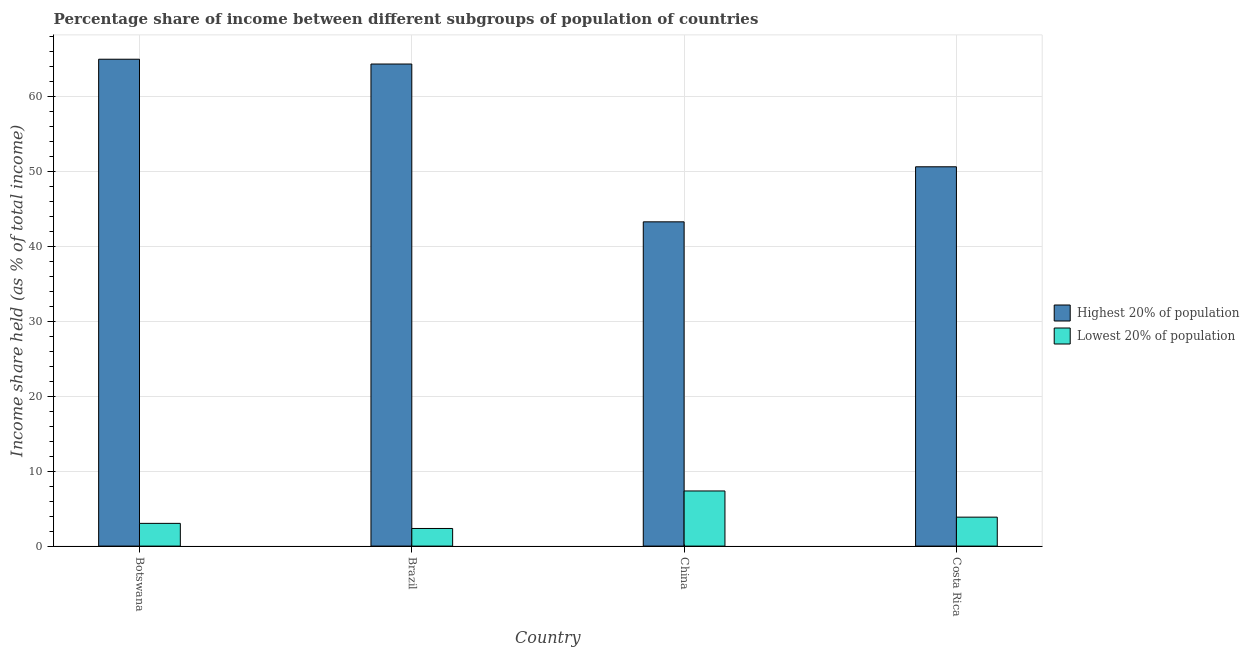Are the number of bars on each tick of the X-axis equal?
Offer a very short reply. Yes. How many bars are there on the 2nd tick from the right?
Ensure brevity in your answer.  2. In how many cases, is the number of bars for a given country not equal to the number of legend labels?
Ensure brevity in your answer.  0. What is the income share held by lowest 20% of the population in Botswana?
Provide a short and direct response. 3.03. Across all countries, what is the maximum income share held by lowest 20% of the population?
Make the answer very short. 7.35. Across all countries, what is the minimum income share held by highest 20% of the population?
Your answer should be compact. 43.23. In which country was the income share held by highest 20% of the population maximum?
Offer a terse response. Botswana. What is the total income share held by lowest 20% of the population in the graph?
Offer a terse response. 16.59. What is the difference between the income share held by highest 20% of the population in Botswana and that in China?
Make the answer very short. 21.68. What is the difference between the income share held by lowest 20% of the population in Brazil and the income share held by highest 20% of the population in Costa Rica?
Keep it short and to the point. -48.22. What is the average income share held by lowest 20% of the population per country?
Your response must be concise. 4.15. What is the difference between the income share held by highest 20% of the population and income share held by lowest 20% of the population in Botswana?
Your answer should be compact. 61.88. In how many countries, is the income share held by lowest 20% of the population greater than 28 %?
Offer a very short reply. 0. What is the ratio of the income share held by highest 20% of the population in China to that in Costa Rica?
Keep it short and to the point. 0.85. Is the income share held by highest 20% of the population in Botswana less than that in Brazil?
Keep it short and to the point. No. Is the difference between the income share held by lowest 20% of the population in Botswana and Costa Rica greater than the difference between the income share held by highest 20% of the population in Botswana and Costa Rica?
Your response must be concise. No. What is the difference between the highest and the second highest income share held by highest 20% of the population?
Your response must be concise. 0.64. What is the difference between the highest and the lowest income share held by lowest 20% of the population?
Your response must be concise. 5. Is the sum of the income share held by lowest 20% of the population in Botswana and Costa Rica greater than the maximum income share held by highest 20% of the population across all countries?
Provide a succinct answer. No. What does the 1st bar from the left in Brazil represents?
Give a very brief answer. Highest 20% of population. What does the 1st bar from the right in Botswana represents?
Give a very brief answer. Lowest 20% of population. Are all the bars in the graph horizontal?
Keep it short and to the point. No. How many countries are there in the graph?
Provide a succinct answer. 4. Does the graph contain any zero values?
Your response must be concise. No. How many legend labels are there?
Your answer should be very brief. 2. How are the legend labels stacked?
Provide a succinct answer. Vertical. What is the title of the graph?
Provide a succinct answer. Percentage share of income between different subgroups of population of countries. Does "Diesel" appear as one of the legend labels in the graph?
Your answer should be very brief. No. What is the label or title of the X-axis?
Offer a very short reply. Country. What is the label or title of the Y-axis?
Keep it short and to the point. Income share held (as % of total income). What is the Income share held (as % of total income) of Highest 20% of population in Botswana?
Give a very brief answer. 64.91. What is the Income share held (as % of total income) of Lowest 20% of population in Botswana?
Provide a short and direct response. 3.03. What is the Income share held (as % of total income) in Highest 20% of population in Brazil?
Provide a succinct answer. 64.27. What is the Income share held (as % of total income) of Lowest 20% of population in Brazil?
Your answer should be compact. 2.35. What is the Income share held (as % of total income) in Highest 20% of population in China?
Offer a terse response. 43.23. What is the Income share held (as % of total income) of Lowest 20% of population in China?
Offer a terse response. 7.35. What is the Income share held (as % of total income) in Highest 20% of population in Costa Rica?
Keep it short and to the point. 50.57. What is the Income share held (as % of total income) of Lowest 20% of population in Costa Rica?
Keep it short and to the point. 3.86. Across all countries, what is the maximum Income share held (as % of total income) in Highest 20% of population?
Give a very brief answer. 64.91. Across all countries, what is the maximum Income share held (as % of total income) in Lowest 20% of population?
Offer a very short reply. 7.35. Across all countries, what is the minimum Income share held (as % of total income) of Highest 20% of population?
Make the answer very short. 43.23. Across all countries, what is the minimum Income share held (as % of total income) in Lowest 20% of population?
Give a very brief answer. 2.35. What is the total Income share held (as % of total income) in Highest 20% of population in the graph?
Give a very brief answer. 222.98. What is the total Income share held (as % of total income) in Lowest 20% of population in the graph?
Provide a short and direct response. 16.59. What is the difference between the Income share held (as % of total income) in Highest 20% of population in Botswana and that in Brazil?
Keep it short and to the point. 0.64. What is the difference between the Income share held (as % of total income) of Lowest 20% of population in Botswana and that in Brazil?
Offer a very short reply. 0.68. What is the difference between the Income share held (as % of total income) of Highest 20% of population in Botswana and that in China?
Keep it short and to the point. 21.68. What is the difference between the Income share held (as % of total income) in Lowest 20% of population in Botswana and that in China?
Give a very brief answer. -4.32. What is the difference between the Income share held (as % of total income) of Highest 20% of population in Botswana and that in Costa Rica?
Provide a short and direct response. 14.34. What is the difference between the Income share held (as % of total income) in Lowest 20% of population in Botswana and that in Costa Rica?
Give a very brief answer. -0.83. What is the difference between the Income share held (as % of total income) in Highest 20% of population in Brazil and that in China?
Your response must be concise. 21.04. What is the difference between the Income share held (as % of total income) of Highest 20% of population in Brazil and that in Costa Rica?
Provide a short and direct response. 13.7. What is the difference between the Income share held (as % of total income) of Lowest 20% of population in Brazil and that in Costa Rica?
Keep it short and to the point. -1.51. What is the difference between the Income share held (as % of total income) in Highest 20% of population in China and that in Costa Rica?
Give a very brief answer. -7.34. What is the difference between the Income share held (as % of total income) of Lowest 20% of population in China and that in Costa Rica?
Your answer should be very brief. 3.49. What is the difference between the Income share held (as % of total income) in Highest 20% of population in Botswana and the Income share held (as % of total income) in Lowest 20% of population in Brazil?
Provide a short and direct response. 62.56. What is the difference between the Income share held (as % of total income) in Highest 20% of population in Botswana and the Income share held (as % of total income) in Lowest 20% of population in China?
Provide a short and direct response. 57.56. What is the difference between the Income share held (as % of total income) of Highest 20% of population in Botswana and the Income share held (as % of total income) of Lowest 20% of population in Costa Rica?
Ensure brevity in your answer.  61.05. What is the difference between the Income share held (as % of total income) in Highest 20% of population in Brazil and the Income share held (as % of total income) in Lowest 20% of population in China?
Offer a terse response. 56.92. What is the difference between the Income share held (as % of total income) of Highest 20% of population in Brazil and the Income share held (as % of total income) of Lowest 20% of population in Costa Rica?
Offer a very short reply. 60.41. What is the difference between the Income share held (as % of total income) of Highest 20% of population in China and the Income share held (as % of total income) of Lowest 20% of population in Costa Rica?
Offer a very short reply. 39.37. What is the average Income share held (as % of total income) in Highest 20% of population per country?
Provide a succinct answer. 55.74. What is the average Income share held (as % of total income) in Lowest 20% of population per country?
Give a very brief answer. 4.15. What is the difference between the Income share held (as % of total income) in Highest 20% of population and Income share held (as % of total income) in Lowest 20% of population in Botswana?
Keep it short and to the point. 61.88. What is the difference between the Income share held (as % of total income) of Highest 20% of population and Income share held (as % of total income) of Lowest 20% of population in Brazil?
Keep it short and to the point. 61.92. What is the difference between the Income share held (as % of total income) of Highest 20% of population and Income share held (as % of total income) of Lowest 20% of population in China?
Provide a succinct answer. 35.88. What is the difference between the Income share held (as % of total income) in Highest 20% of population and Income share held (as % of total income) in Lowest 20% of population in Costa Rica?
Your answer should be compact. 46.71. What is the ratio of the Income share held (as % of total income) in Lowest 20% of population in Botswana to that in Brazil?
Offer a very short reply. 1.29. What is the ratio of the Income share held (as % of total income) in Highest 20% of population in Botswana to that in China?
Make the answer very short. 1.5. What is the ratio of the Income share held (as % of total income) of Lowest 20% of population in Botswana to that in China?
Your answer should be very brief. 0.41. What is the ratio of the Income share held (as % of total income) in Highest 20% of population in Botswana to that in Costa Rica?
Provide a succinct answer. 1.28. What is the ratio of the Income share held (as % of total income) in Lowest 20% of population in Botswana to that in Costa Rica?
Make the answer very short. 0.79. What is the ratio of the Income share held (as % of total income) of Highest 20% of population in Brazil to that in China?
Ensure brevity in your answer.  1.49. What is the ratio of the Income share held (as % of total income) in Lowest 20% of population in Brazil to that in China?
Provide a succinct answer. 0.32. What is the ratio of the Income share held (as % of total income) of Highest 20% of population in Brazil to that in Costa Rica?
Offer a terse response. 1.27. What is the ratio of the Income share held (as % of total income) of Lowest 20% of population in Brazil to that in Costa Rica?
Offer a very short reply. 0.61. What is the ratio of the Income share held (as % of total income) of Highest 20% of population in China to that in Costa Rica?
Keep it short and to the point. 0.85. What is the ratio of the Income share held (as % of total income) in Lowest 20% of population in China to that in Costa Rica?
Keep it short and to the point. 1.9. What is the difference between the highest and the second highest Income share held (as % of total income) of Highest 20% of population?
Give a very brief answer. 0.64. What is the difference between the highest and the second highest Income share held (as % of total income) of Lowest 20% of population?
Offer a very short reply. 3.49. What is the difference between the highest and the lowest Income share held (as % of total income) in Highest 20% of population?
Your response must be concise. 21.68. 